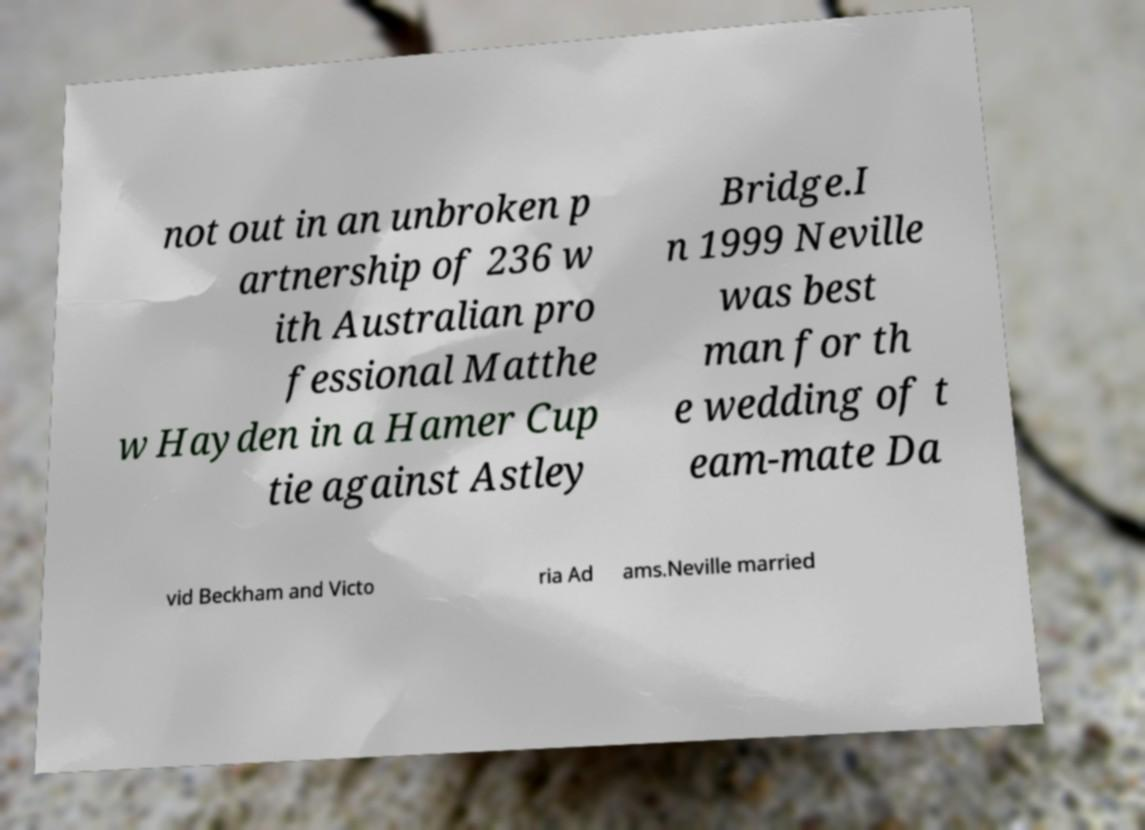Can you accurately transcribe the text from the provided image for me? not out in an unbroken p artnership of 236 w ith Australian pro fessional Matthe w Hayden in a Hamer Cup tie against Astley Bridge.I n 1999 Neville was best man for th e wedding of t eam-mate Da vid Beckham and Victo ria Ad ams.Neville married 